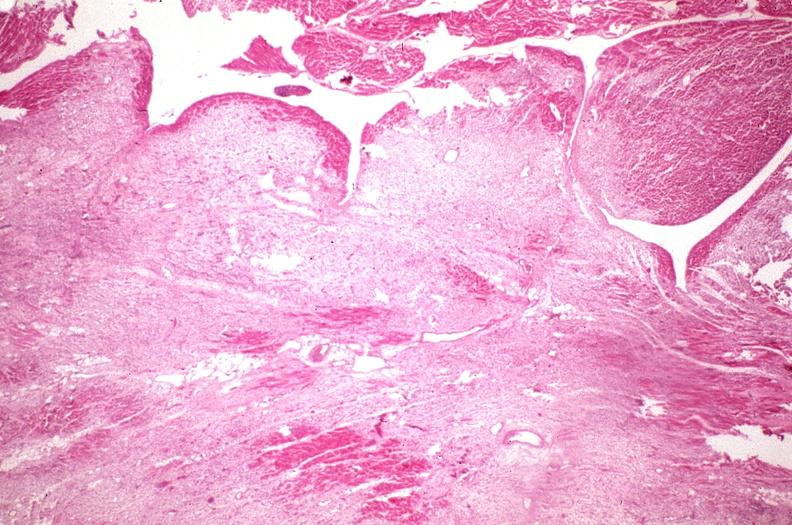s cranial artery present?
Answer the question using a single word or phrase. No 